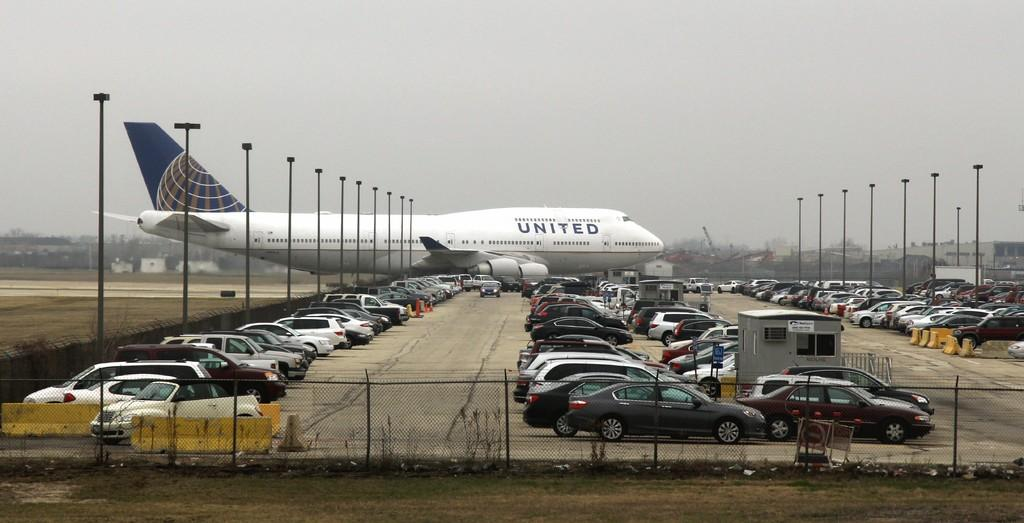Provide a one-sentence caption for the provided image. A United Airlines plane taxis behind a large parking lot. 